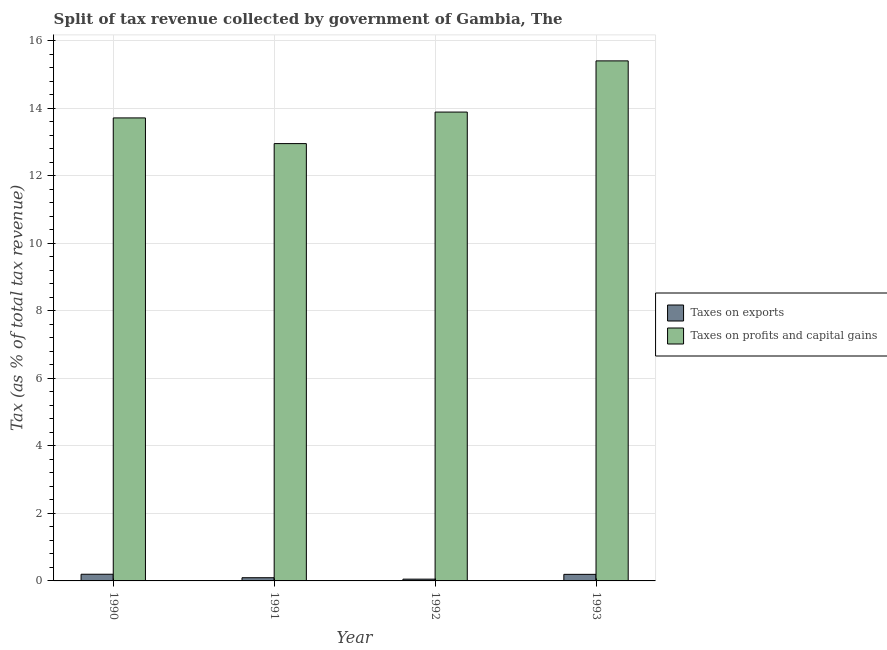How many different coloured bars are there?
Offer a terse response. 2. How many bars are there on the 1st tick from the left?
Keep it short and to the point. 2. How many bars are there on the 3rd tick from the right?
Make the answer very short. 2. What is the label of the 4th group of bars from the left?
Provide a short and direct response. 1993. In how many cases, is the number of bars for a given year not equal to the number of legend labels?
Your response must be concise. 0. What is the percentage of revenue obtained from taxes on exports in 1991?
Provide a short and direct response. 0.09. Across all years, what is the maximum percentage of revenue obtained from taxes on profits and capital gains?
Offer a very short reply. 15.41. Across all years, what is the minimum percentage of revenue obtained from taxes on profits and capital gains?
Your response must be concise. 12.96. What is the total percentage of revenue obtained from taxes on profits and capital gains in the graph?
Your answer should be compact. 55.98. What is the difference between the percentage of revenue obtained from taxes on exports in 1991 and that in 1992?
Provide a short and direct response. 0.04. What is the difference between the percentage of revenue obtained from taxes on profits and capital gains in 1991 and the percentage of revenue obtained from taxes on exports in 1993?
Offer a very short reply. -2.45. What is the average percentage of revenue obtained from taxes on profits and capital gains per year?
Provide a short and direct response. 14. In the year 1990, what is the difference between the percentage of revenue obtained from taxes on exports and percentage of revenue obtained from taxes on profits and capital gains?
Give a very brief answer. 0. What is the ratio of the percentage of revenue obtained from taxes on profits and capital gains in 1990 to that in 1992?
Your answer should be compact. 0.99. Is the difference between the percentage of revenue obtained from taxes on exports in 1991 and 1993 greater than the difference between the percentage of revenue obtained from taxes on profits and capital gains in 1991 and 1993?
Ensure brevity in your answer.  No. What is the difference between the highest and the second highest percentage of revenue obtained from taxes on exports?
Make the answer very short. 0. What is the difference between the highest and the lowest percentage of revenue obtained from taxes on profits and capital gains?
Give a very brief answer. 2.45. What does the 1st bar from the left in 1990 represents?
Your response must be concise. Taxes on exports. What does the 1st bar from the right in 1990 represents?
Provide a short and direct response. Taxes on profits and capital gains. How many years are there in the graph?
Offer a terse response. 4. What is the difference between two consecutive major ticks on the Y-axis?
Offer a very short reply. 2. Are the values on the major ticks of Y-axis written in scientific E-notation?
Provide a succinct answer. No. Where does the legend appear in the graph?
Your answer should be very brief. Center right. How many legend labels are there?
Offer a very short reply. 2. How are the legend labels stacked?
Give a very brief answer. Vertical. What is the title of the graph?
Make the answer very short. Split of tax revenue collected by government of Gambia, The. Does "Crop" appear as one of the legend labels in the graph?
Offer a terse response. No. What is the label or title of the X-axis?
Give a very brief answer. Year. What is the label or title of the Y-axis?
Your answer should be very brief. Tax (as % of total tax revenue). What is the Tax (as % of total tax revenue) in Taxes on exports in 1990?
Offer a terse response. 0.2. What is the Tax (as % of total tax revenue) in Taxes on profits and capital gains in 1990?
Provide a succinct answer. 13.72. What is the Tax (as % of total tax revenue) of Taxes on exports in 1991?
Ensure brevity in your answer.  0.09. What is the Tax (as % of total tax revenue) in Taxes on profits and capital gains in 1991?
Your response must be concise. 12.96. What is the Tax (as % of total tax revenue) of Taxes on exports in 1992?
Give a very brief answer. 0.05. What is the Tax (as % of total tax revenue) in Taxes on profits and capital gains in 1992?
Ensure brevity in your answer.  13.89. What is the Tax (as % of total tax revenue) of Taxes on exports in 1993?
Ensure brevity in your answer.  0.19. What is the Tax (as % of total tax revenue) of Taxes on profits and capital gains in 1993?
Offer a terse response. 15.41. Across all years, what is the maximum Tax (as % of total tax revenue) in Taxes on exports?
Keep it short and to the point. 0.2. Across all years, what is the maximum Tax (as % of total tax revenue) in Taxes on profits and capital gains?
Give a very brief answer. 15.41. Across all years, what is the minimum Tax (as % of total tax revenue) in Taxes on exports?
Provide a succinct answer. 0.05. Across all years, what is the minimum Tax (as % of total tax revenue) in Taxes on profits and capital gains?
Offer a very short reply. 12.96. What is the total Tax (as % of total tax revenue) in Taxes on exports in the graph?
Give a very brief answer. 0.54. What is the total Tax (as % of total tax revenue) of Taxes on profits and capital gains in the graph?
Offer a terse response. 55.98. What is the difference between the Tax (as % of total tax revenue) of Taxes on exports in 1990 and that in 1991?
Give a very brief answer. 0.1. What is the difference between the Tax (as % of total tax revenue) in Taxes on profits and capital gains in 1990 and that in 1991?
Provide a succinct answer. 0.76. What is the difference between the Tax (as % of total tax revenue) of Taxes on exports in 1990 and that in 1992?
Your answer should be very brief. 0.15. What is the difference between the Tax (as % of total tax revenue) in Taxes on profits and capital gains in 1990 and that in 1992?
Provide a short and direct response. -0.17. What is the difference between the Tax (as % of total tax revenue) of Taxes on exports in 1990 and that in 1993?
Provide a succinct answer. 0. What is the difference between the Tax (as % of total tax revenue) in Taxes on profits and capital gains in 1990 and that in 1993?
Ensure brevity in your answer.  -1.69. What is the difference between the Tax (as % of total tax revenue) in Taxes on exports in 1991 and that in 1992?
Your response must be concise. 0.04. What is the difference between the Tax (as % of total tax revenue) of Taxes on profits and capital gains in 1991 and that in 1992?
Your answer should be compact. -0.93. What is the difference between the Tax (as % of total tax revenue) of Taxes on profits and capital gains in 1991 and that in 1993?
Provide a short and direct response. -2.45. What is the difference between the Tax (as % of total tax revenue) of Taxes on exports in 1992 and that in 1993?
Ensure brevity in your answer.  -0.14. What is the difference between the Tax (as % of total tax revenue) of Taxes on profits and capital gains in 1992 and that in 1993?
Ensure brevity in your answer.  -1.52. What is the difference between the Tax (as % of total tax revenue) of Taxes on exports in 1990 and the Tax (as % of total tax revenue) of Taxes on profits and capital gains in 1991?
Provide a succinct answer. -12.76. What is the difference between the Tax (as % of total tax revenue) in Taxes on exports in 1990 and the Tax (as % of total tax revenue) in Taxes on profits and capital gains in 1992?
Keep it short and to the point. -13.7. What is the difference between the Tax (as % of total tax revenue) in Taxes on exports in 1990 and the Tax (as % of total tax revenue) in Taxes on profits and capital gains in 1993?
Offer a terse response. -15.21. What is the difference between the Tax (as % of total tax revenue) of Taxes on exports in 1991 and the Tax (as % of total tax revenue) of Taxes on profits and capital gains in 1992?
Offer a terse response. -13.8. What is the difference between the Tax (as % of total tax revenue) of Taxes on exports in 1991 and the Tax (as % of total tax revenue) of Taxes on profits and capital gains in 1993?
Provide a short and direct response. -15.32. What is the difference between the Tax (as % of total tax revenue) of Taxes on exports in 1992 and the Tax (as % of total tax revenue) of Taxes on profits and capital gains in 1993?
Offer a terse response. -15.36. What is the average Tax (as % of total tax revenue) of Taxes on exports per year?
Your answer should be very brief. 0.14. What is the average Tax (as % of total tax revenue) in Taxes on profits and capital gains per year?
Your answer should be very brief. 14. In the year 1990, what is the difference between the Tax (as % of total tax revenue) of Taxes on exports and Tax (as % of total tax revenue) of Taxes on profits and capital gains?
Provide a succinct answer. -13.52. In the year 1991, what is the difference between the Tax (as % of total tax revenue) in Taxes on exports and Tax (as % of total tax revenue) in Taxes on profits and capital gains?
Your answer should be very brief. -12.86. In the year 1992, what is the difference between the Tax (as % of total tax revenue) in Taxes on exports and Tax (as % of total tax revenue) in Taxes on profits and capital gains?
Provide a succinct answer. -13.84. In the year 1993, what is the difference between the Tax (as % of total tax revenue) in Taxes on exports and Tax (as % of total tax revenue) in Taxes on profits and capital gains?
Ensure brevity in your answer.  -15.22. What is the ratio of the Tax (as % of total tax revenue) in Taxes on exports in 1990 to that in 1991?
Provide a short and direct response. 2.09. What is the ratio of the Tax (as % of total tax revenue) of Taxes on profits and capital gains in 1990 to that in 1991?
Your answer should be very brief. 1.06. What is the ratio of the Tax (as % of total tax revenue) in Taxes on exports in 1990 to that in 1992?
Offer a very short reply. 3.76. What is the ratio of the Tax (as % of total tax revenue) of Taxes on profits and capital gains in 1990 to that in 1992?
Provide a succinct answer. 0.99. What is the ratio of the Tax (as % of total tax revenue) in Taxes on exports in 1990 to that in 1993?
Make the answer very short. 1.02. What is the ratio of the Tax (as % of total tax revenue) in Taxes on profits and capital gains in 1990 to that in 1993?
Your response must be concise. 0.89. What is the ratio of the Tax (as % of total tax revenue) of Taxes on exports in 1991 to that in 1992?
Your answer should be very brief. 1.8. What is the ratio of the Tax (as % of total tax revenue) in Taxes on profits and capital gains in 1991 to that in 1992?
Your answer should be compact. 0.93. What is the ratio of the Tax (as % of total tax revenue) in Taxes on exports in 1991 to that in 1993?
Offer a terse response. 0.49. What is the ratio of the Tax (as % of total tax revenue) in Taxes on profits and capital gains in 1991 to that in 1993?
Offer a terse response. 0.84. What is the ratio of the Tax (as % of total tax revenue) of Taxes on exports in 1992 to that in 1993?
Your answer should be compact. 0.27. What is the ratio of the Tax (as % of total tax revenue) in Taxes on profits and capital gains in 1992 to that in 1993?
Your response must be concise. 0.9. What is the difference between the highest and the second highest Tax (as % of total tax revenue) in Taxes on exports?
Your response must be concise. 0. What is the difference between the highest and the second highest Tax (as % of total tax revenue) of Taxes on profits and capital gains?
Make the answer very short. 1.52. What is the difference between the highest and the lowest Tax (as % of total tax revenue) of Taxes on exports?
Provide a succinct answer. 0.15. What is the difference between the highest and the lowest Tax (as % of total tax revenue) of Taxes on profits and capital gains?
Ensure brevity in your answer.  2.45. 